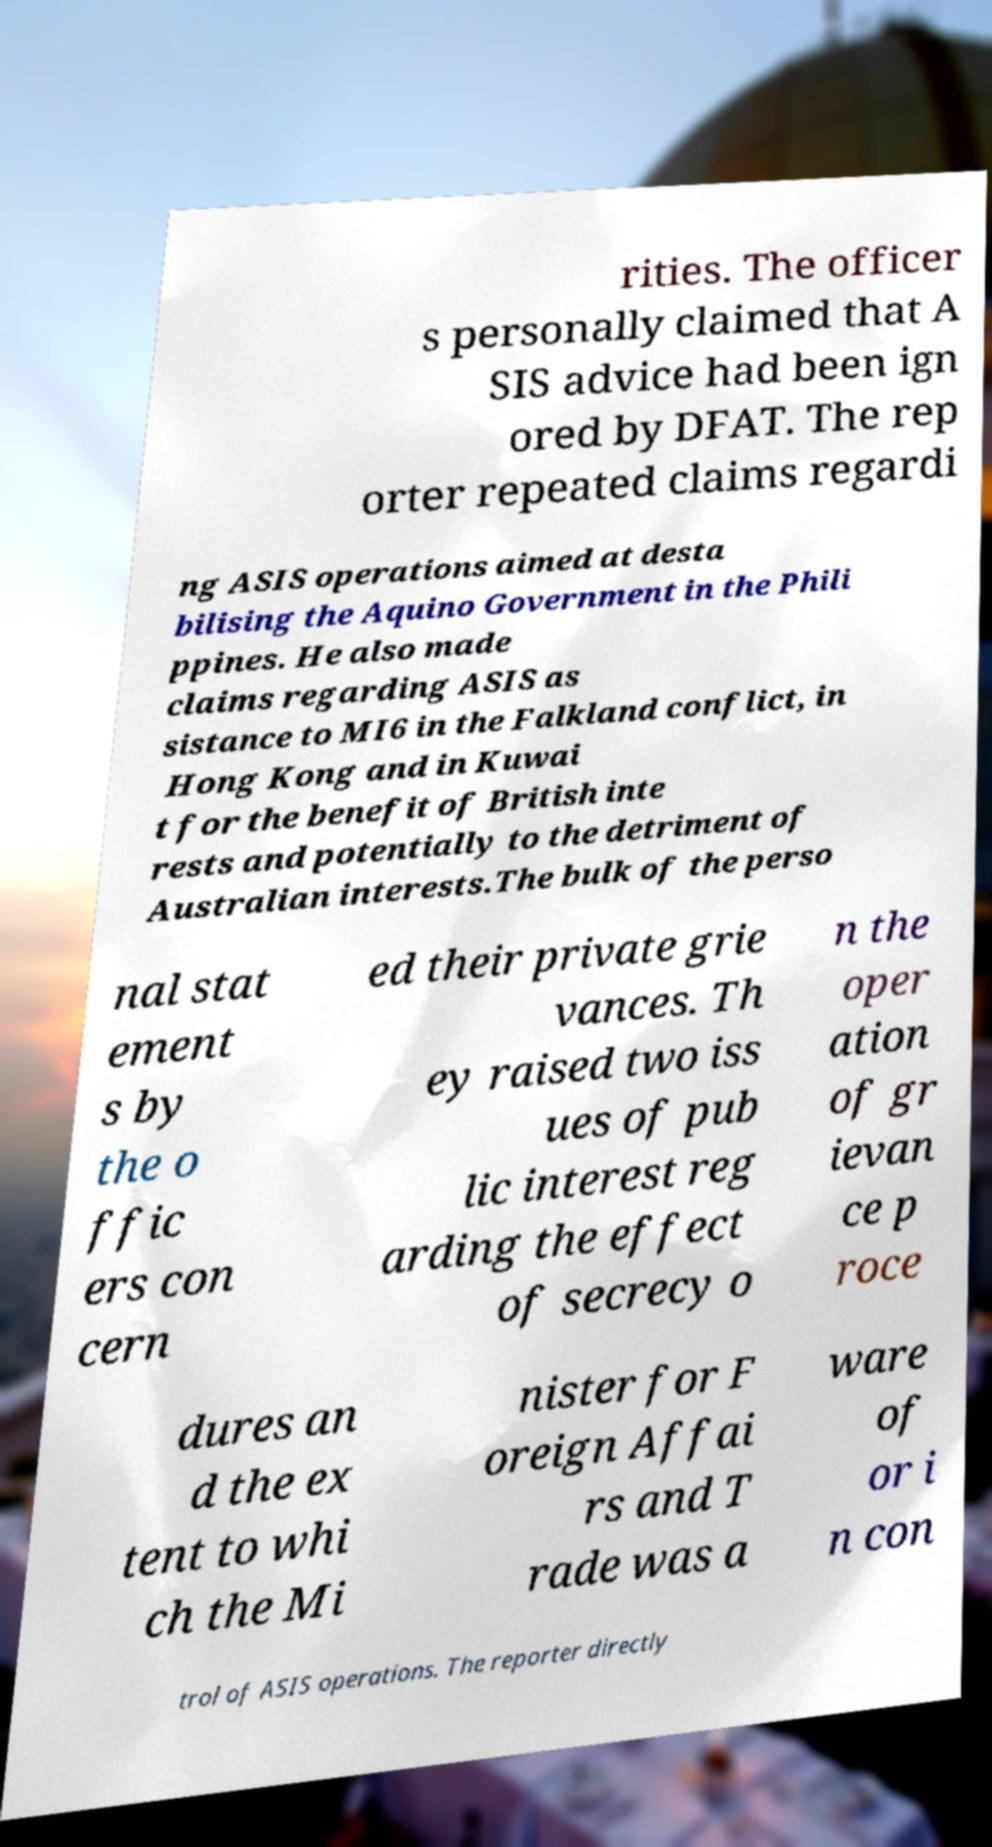Can you accurately transcribe the text from the provided image for me? rities. The officer s personally claimed that A SIS advice had been ign ored by DFAT. The rep orter repeated claims regardi ng ASIS operations aimed at desta bilising the Aquino Government in the Phili ppines. He also made claims regarding ASIS as sistance to MI6 in the Falkland conflict, in Hong Kong and in Kuwai t for the benefit of British inte rests and potentially to the detriment of Australian interests.The bulk of the perso nal stat ement s by the o ffic ers con cern ed their private grie vances. Th ey raised two iss ues of pub lic interest reg arding the effect of secrecy o n the oper ation of gr ievan ce p roce dures an d the ex tent to whi ch the Mi nister for F oreign Affai rs and T rade was a ware of or i n con trol of ASIS operations. The reporter directly 